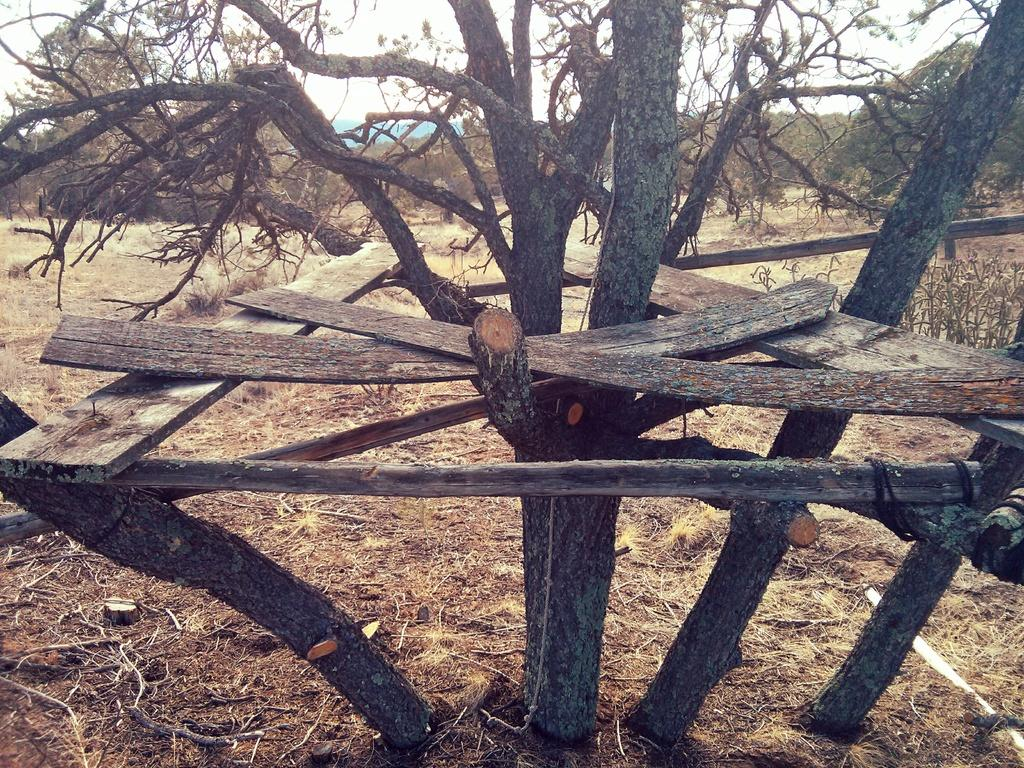What is on the tree in the foreground of the image? There are wooden planks on a tree in the foreground of the image. What can be seen in the background of the image? There is land and trees visible in the background of the image. What else is visible in the background of the image? The sky is visible in the background of the image. Can you see any windows in the image? There are no windows present in the image. 